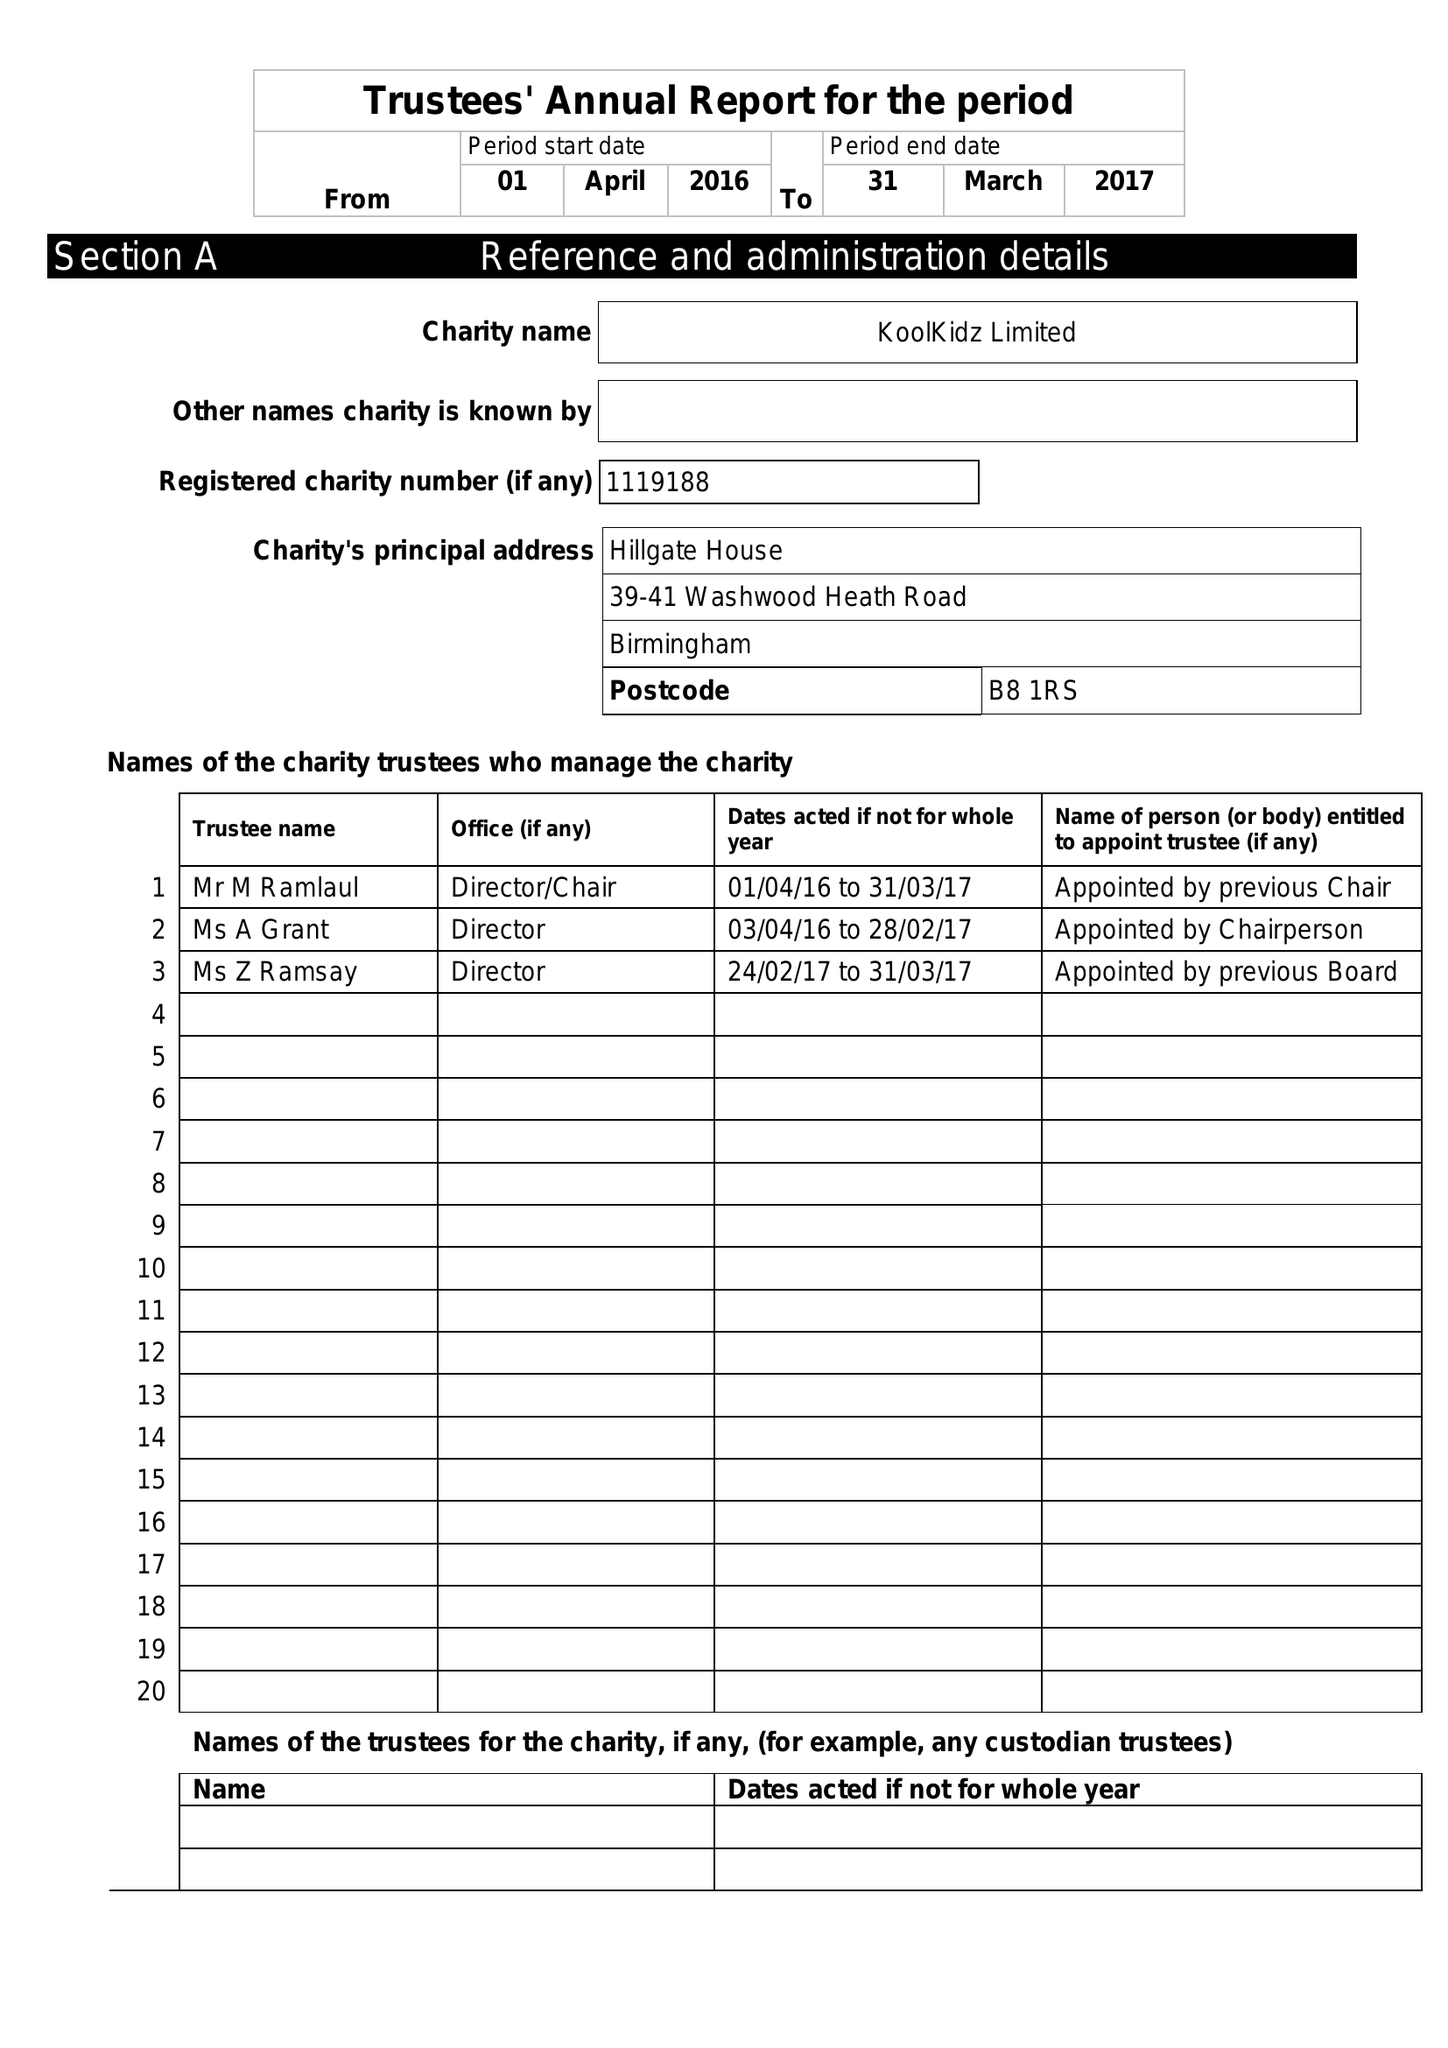What is the value for the spending_annually_in_british_pounds?
Answer the question using a single word or phrase. 189548.00 